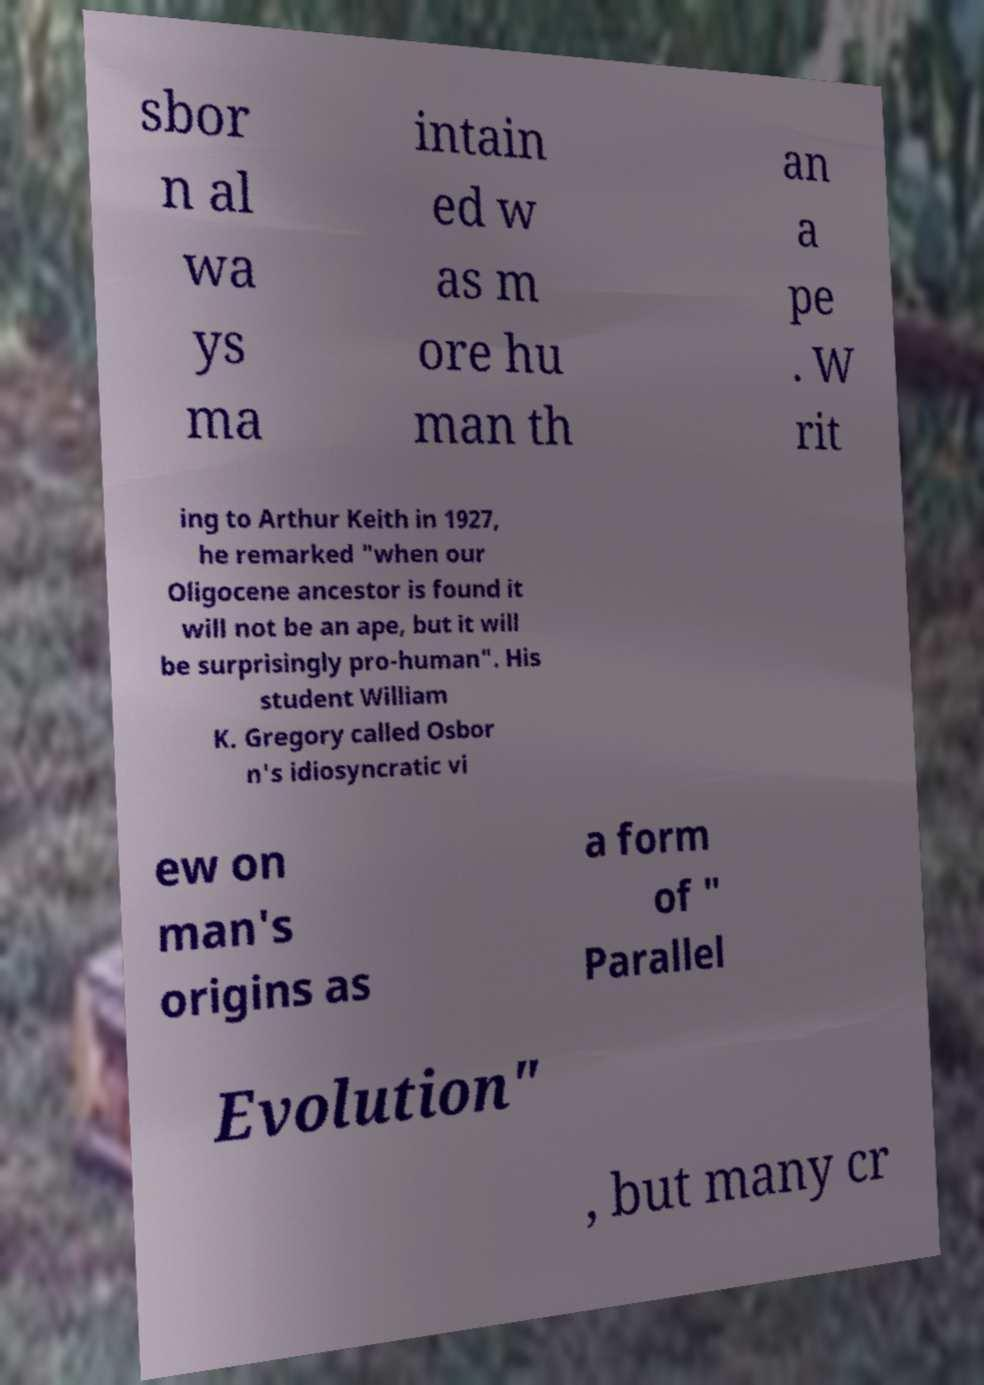What messages or text are displayed in this image? I need them in a readable, typed format. sbor n al wa ys ma intain ed w as m ore hu man th an a pe . W rit ing to Arthur Keith in 1927, he remarked "when our Oligocene ancestor is found it will not be an ape, but it will be surprisingly pro-human". His student William K. Gregory called Osbor n's idiosyncratic vi ew on man's origins as a form of " Parallel Evolution" , but many cr 